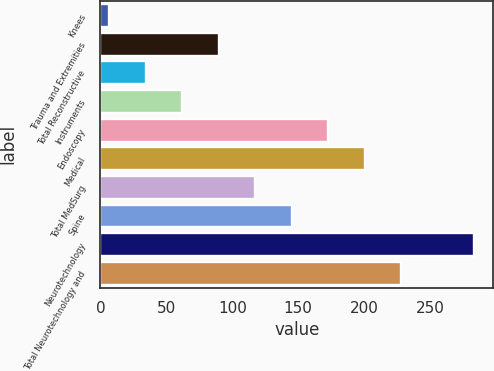Convert chart. <chart><loc_0><loc_0><loc_500><loc_500><bar_chart><fcel>Knees<fcel>Trauma and Extremities<fcel>Total Reconstructive<fcel>Instruments<fcel>Endoscopy<fcel>Medical<fcel>Total MedSurg<fcel>Spine<fcel>Neurotechnology<fcel>Total Neurotechnology and<nl><fcel>6.8<fcel>89.84<fcel>34.48<fcel>62.16<fcel>172.88<fcel>200.56<fcel>117.52<fcel>145.2<fcel>283.6<fcel>228.24<nl></chart> 